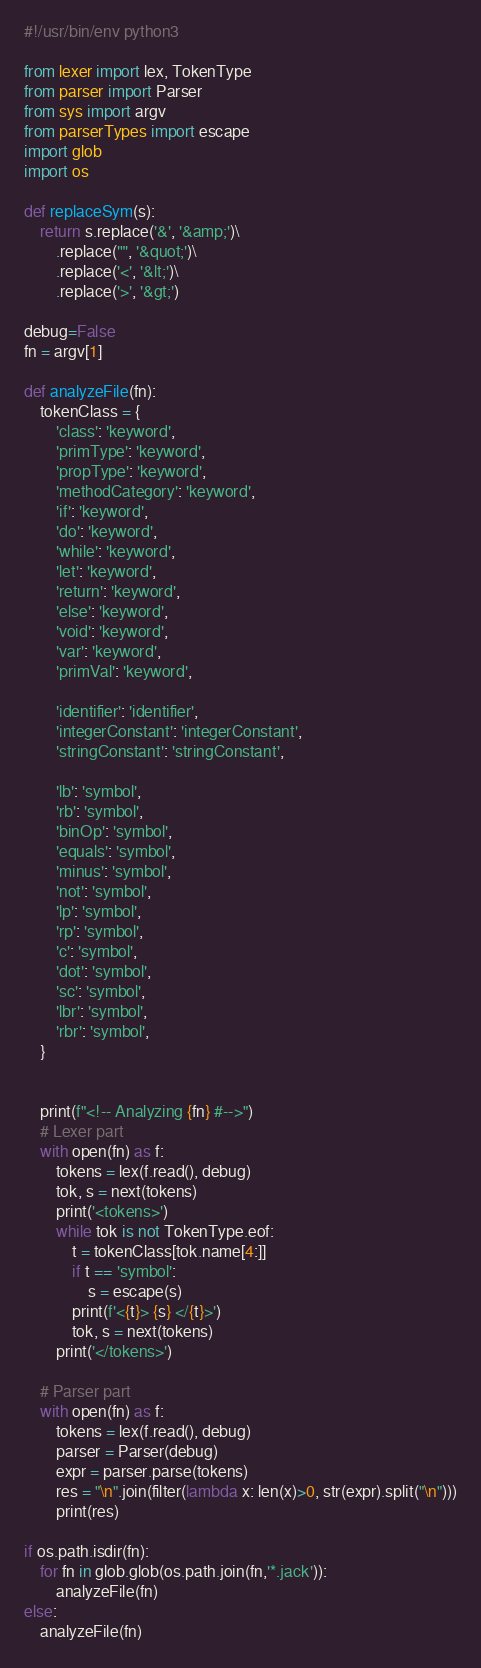Convert code to text. <code><loc_0><loc_0><loc_500><loc_500><_Python_>#!/usr/bin/env python3

from lexer import lex, TokenType
from parser import Parser
from sys import argv
from parserTypes import escape
import glob
import os

def replaceSym(s):
    return s.replace('&', '&amp;')\
        .replace('"', '&quot;')\
        .replace('<', '&lt;')\
        .replace('>', '&gt;')

debug=False
fn = argv[1]

def analyzeFile(fn):
    tokenClass = {
        'class': 'keyword',
        'primType': 'keyword',
        'propType': 'keyword',
        'methodCategory': 'keyword',
        'if': 'keyword',
        'do': 'keyword',
        'while': 'keyword',
        'let': 'keyword',
        'return': 'keyword',
        'else': 'keyword',
        'void': 'keyword',
        'var': 'keyword',
        'primVal': 'keyword',

        'identifier': 'identifier',
        'integerConstant': 'integerConstant',
        'stringConstant': 'stringConstant',

        'lb': 'symbol',
        'rb': 'symbol',
        'binOp': 'symbol',
        'equals': 'symbol',
        'minus': 'symbol',
        'not': 'symbol',
        'lp': 'symbol',
        'rp': 'symbol',
        'c': 'symbol',
        'dot': 'symbol',
        'sc': 'symbol',
        'lbr': 'symbol',
        'rbr': 'symbol',
    }


    print(f"<!-- Analyzing {fn} #-->")
    # Lexer part
    with open(fn) as f:
        tokens = lex(f.read(), debug)
        tok, s = next(tokens)
        print('<tokens>')
        while tok is not TokenType.eof:
            t = tokenClass[tok.name[4:]]
            if t == 'symbol':
                s = escape(s)
            print(f'<{t}> {s} </{t}>')
            tok, s = next(tokens)
        print('</tokens>')

    # Parser part
    with open(fn) as f:
        tokens = lex(f.read(), debug)
        parser = Parser(debug)
        expr = parser.parse(tokens)
        res = "\n".join(filter(lambda x: len(x)>0, str(expr).split("\n")))
        print(res)

if os.path.isdir(fn):
    for fn in glob.glob(os.path.join(fn,'*.jack')):
        analyzeFile(fn)
else:
    analyzeFile(fn)
</code> 